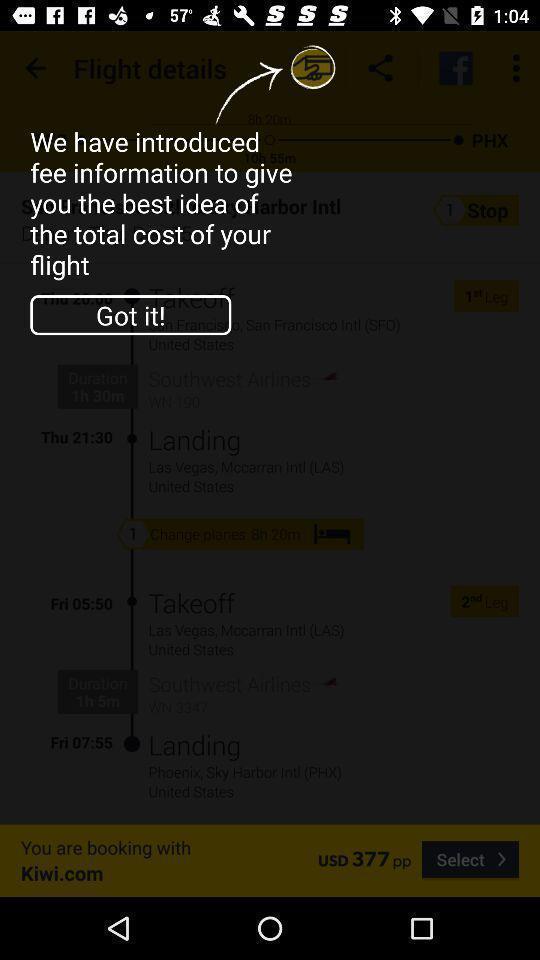Summarize the information in this screenshot. Screen displaying the notification from an app. 